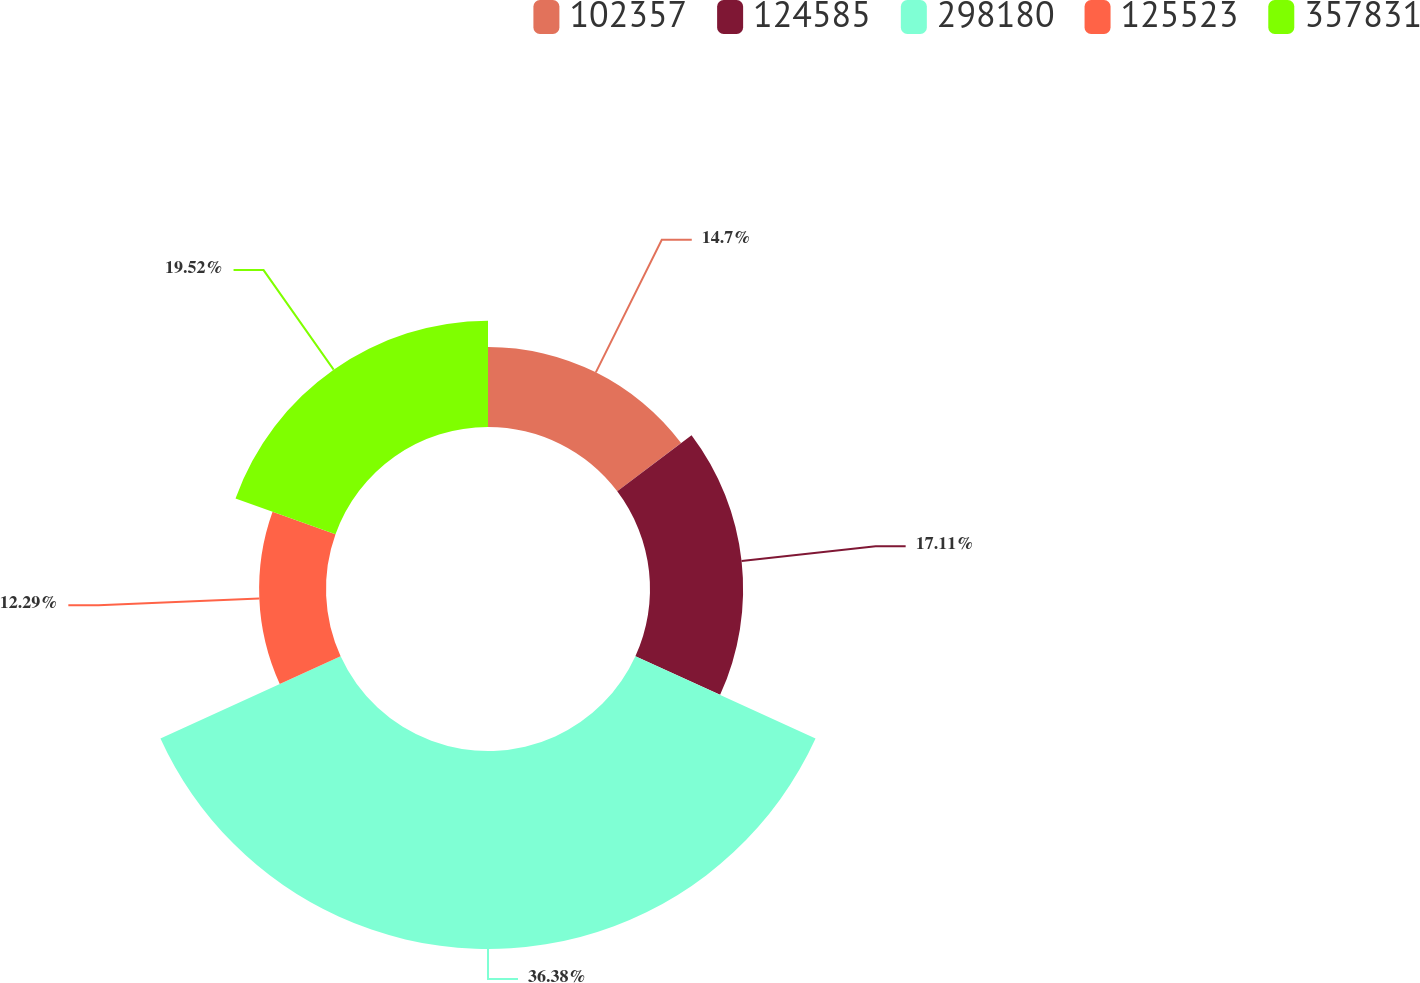Convert chart to OTSL. <chart><loc_0><loc_0><loc_500><loc_500><pie_chart><fcel>102357<fcel>124585<fcel>298180<fcel>125523<fcel>357831<nl><fcel>14.7%<fcel>17.11%<fcel>36.38%<fcel>12.29%<fcel>19.52%<nl></chart> 